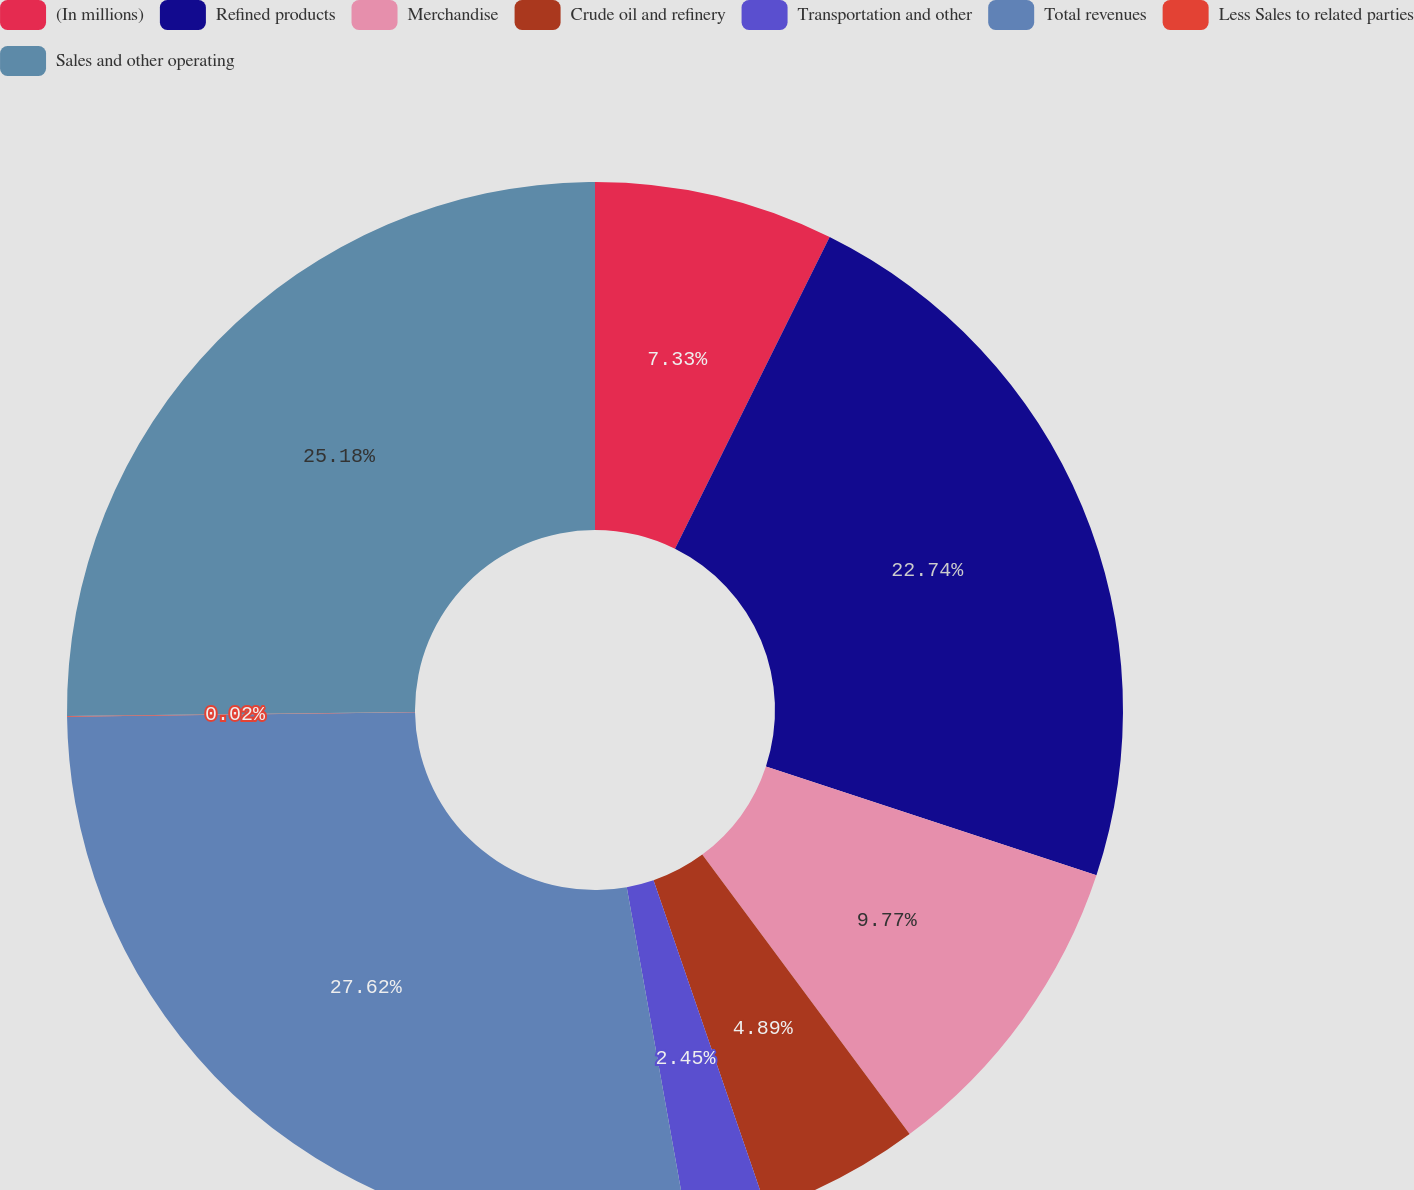Convert chart. <chart><loc_0><loc_0><loc_500><loc_500><pie_chart><fcel>(In millions)<fcel>Refined products<fcel>Merchandise<fcel>Crude oil and refinery<fcel>Transportation and other<fcel>Total revenues<fcel>Less Sales to related parties<fcel>Sales and other operating<nl><fcel>7.33%<fcel>22.74%<fcel>9.77%<fcel>4.89%<fcel>2.45%<fcel>27.62%<fcel>0.02%<fcel>25.18%<nl></chart> 